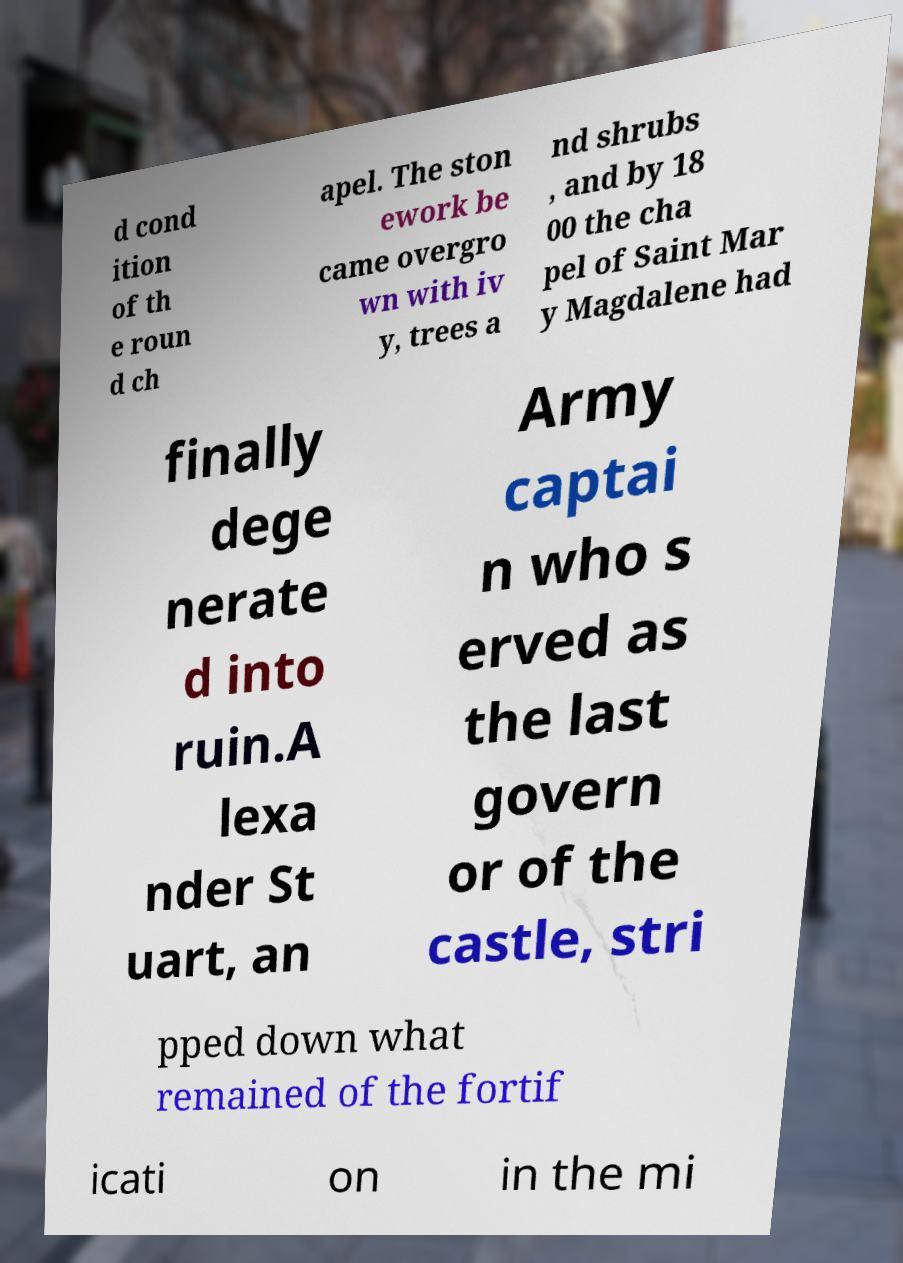Please read and relay the text visible in this image. What does it say? d cond ition of th e roun d ch apel. The ston ework be came overgro wn with iv y, trees a nd shrubs , and by 18 00 the cha pel of Saint Mar y Magdalene had finally dege nerate d into ruin.A lexa nder St uart, an Army captai n who s erved as the last govern or of the castle, stri pped down what remained of the fortif icati on in the mi 